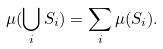Convert formula to latex. <formula><loc_0><loc_0><loc_500><loc_500>\mu ( \bigcup _ { i } S _ { i } ) = \sum _ { i } \mu ( S _ { i } ) .</formula> 